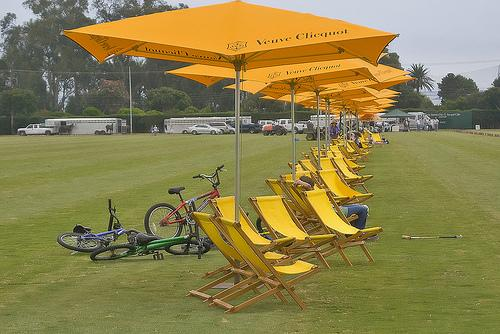What is the object lying on the grass? The object lying on the grass is a polo mallet at coordinates (390, 203). Describe the objects near the edge of the image. There are trees in the distance at coordinates (1, 23), and part of a green ground at coordinates (405, 277). Count the number of bicycles on the ground and describe their conditions. There are three bicycles on the ground: a blue bike, a green bike, and a red bike laying in the grass. List the location and description of chairs in the image. There are yellow and wooden chairs located at coordinates (203, 191), and a person is sitting on a chair at coordinates (250, 172). There are also many yellow chairs at coordinates (228, 116). Describe the position of the white truck and specify if there is an accompanying vehicle. The white truck is located at coordinates (0, 95) and has a trailer attached. What are the people on the grass doing? The people on the grass are standing around, possibly in a parking lot at coordinates (322, 113). Identify and describe a person sitting on a chair in the image. A man is sitting on a yellow lounge chair at coordinates (294, 172). What kind of car is parked and where is it located in the image? A silver sedan is parked at coordinates (187, 121). Describe the location and appearance of the umbrellas in the image. There are large yellow umbrellas lining up in a row at coordinates (64, 11), and a large green umbrella at coordinates (382, 105). Identify the colors of the bikes in the image and their location. There are three bikes: a blue bike laying on the ground at coordinates (34, 190), a green bike laying on the ground at coordinates (96, 210), and a red and black bike at coordinates (151, 154). Identify interactions between objects in the image. person sits on chair, bikes on grass, horses by truck What attributes can be assigned to the yellow chairs in the image? foldable, outdoor, numerous, arranged Describe the arrangement of the umbrellas and chairs. umbrellas over chairs, lined up in a row List the colors of the bikes in the image. blue, green, red and black Describe the scene with the green bike. green bike laying on green grass, near people and objects Is there a green umbrella in the image? yes Can you find a blue truck parked near the white truck? There is no mention of a blue truck in the image, only a white truck and trailer are mentioned. What is the overall sentiment or atmosphere of the image? casual and summery Are there any motorcycles among the bikes on the grass? There are no mentions of motorcycles in the image, only bicycles are mentioned. Describe the mood of the scene in the image. relaxed and social Is there a cat lounging on the grass near the bikes? There is no mention of a cat in the image, only people and bikes are present on the grass. Do you notice a row of pink umbrellas next to the yellow ones? There are no mentions of pink umbrellas in the image, only yellow and green umbrellas are present. Which of the following is present in the image: (a) horses, (b) a mountain, (c) a lake. (a) horses Segment the objects within the image based on their semantic differences. bikes, chairs, umbrellas, people, vehicles, nature, small objects What color is the lounge chair in the image? yellow Is the person sitting on a green chair instead of a yellow one? There is no mention of a green chair in the image, only yellow chairs. Rate the overall quality of the image from 1 to 5, where 5 is the highest. 4 Assess the quality of the image in terms of lighting and focus. good lighting and focus What car can be found in the image? silver sedan Are there any unusual objects or elements in the image? polo mallet laying on grass Describe the interaction between a person and an object in the image. a man is sitting in a folding chair Read any text visible in the image. no visible text Locate the person sitting on a yellow lounge chair. X:294 Y:172 Width:84 Height:84 What object can be found laying on the grass near the bicycles? polo mallet Can you spot a purple bike instead of the blue, green, and red bikes? There are no mentions of a purple bike in the image, only blue, green, and red bikes are present. 